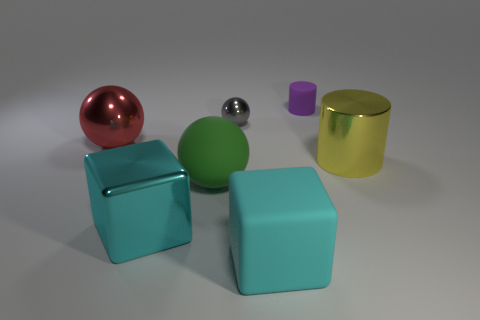How many other big things are the same shape as the large red object?
Offer a very short reply. 1. Is the shape of the big yellow metal thing that is in front of the purple rubber object the same as the small thing behind the tiny gray shiny sphere?
Give a very brief answer. Yes. What shape is the big rubber thing that is the same color as the metallic cube?
Your answer should be very brief. Cube. How many purple matte cylinders have the same size as the red metal object?
Your answer should be very brief. 0. How many things are either large shiny objects that are in front of the large shiny sphere or big things that are left of the tiny purple matte thing?
Offer a terse response. 5. Is the material of the cylinder in front of the small matte thing the same as the big ball that is in front of the large red thing?
Give a very brief answer. No. What shape is the matte thing that is behind the metallic thing that is right of the purple matte cylinder?
Give a very brief answer. Cylinder. Is there anything else that has the same color as the big rubber cube?
Provide a short and direct response. Yes. There is a big metal object behind the cylinder that is in front of the tiny cylinder; are there any rubber spheres that are on the left side of it?
Provide a succinct answer. No. Does the big block left of the small gray metal thing have the same color as the large block on the right side of the green rubber thing?
Your response must be concise. Yes. 